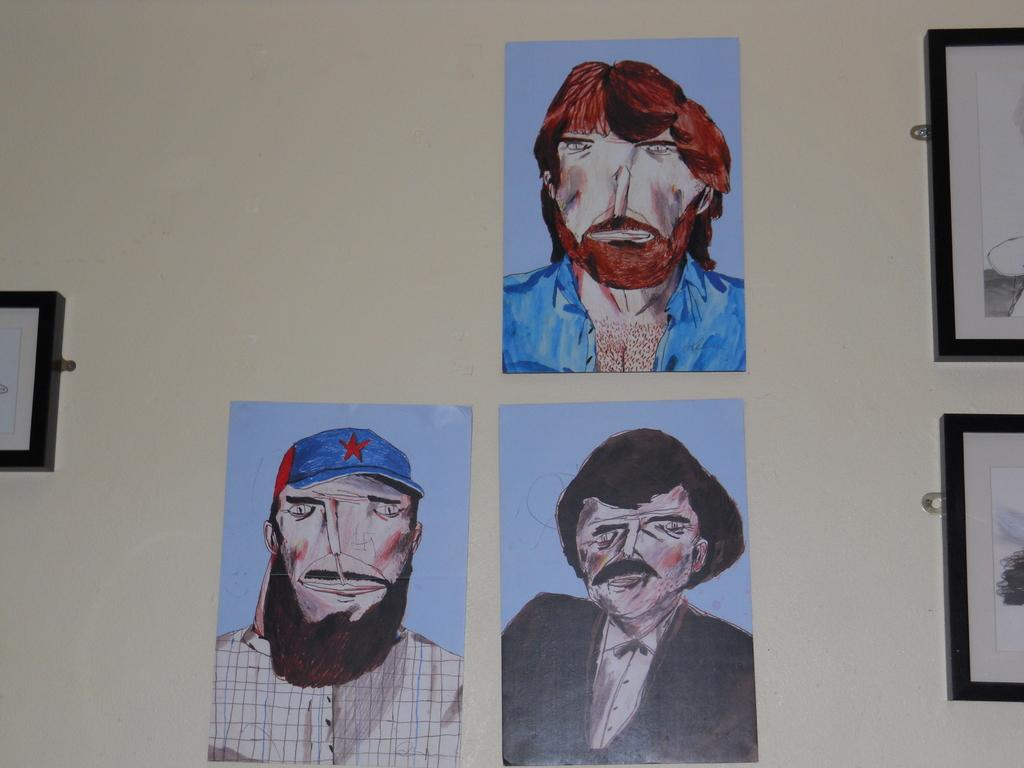What can be seen on the wall in the image? There are sketches and frames on the wall. What type of artwork is displayed in the frames? The provided facts do not specify the type of artwork in the frames. How are the sketches and frames arranged on the wall? The provided facts do not specify the arrangement of the sketches and frames on the wall. What type of drum can be heard playing in the background of the image? There is no drum or sound present in the image; it only shows sketches and frames on the wall. 